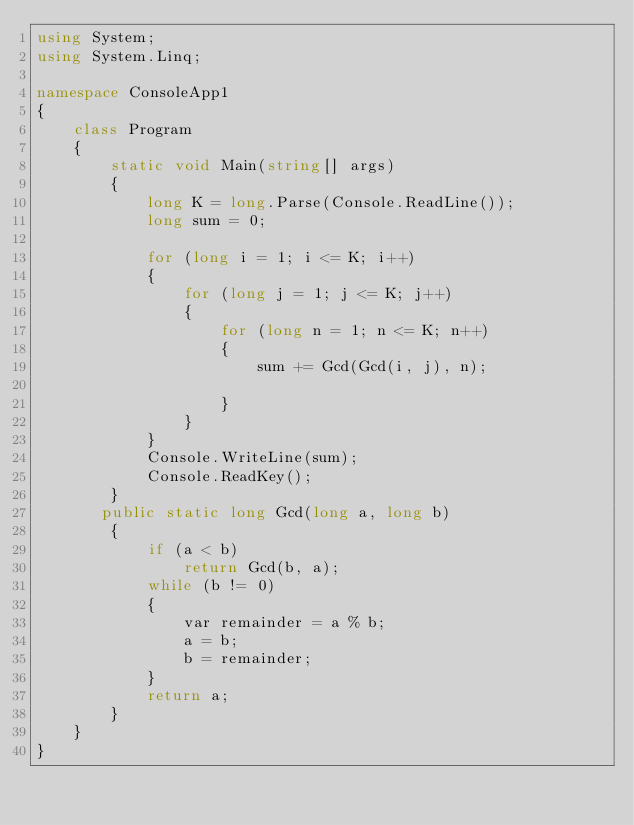Convert code to text. <code><loc_0><loc_0><loc_500><loc_500><_C#_>using System;
using System.Linq;

namespace ConsoleApp1
{
    class Program
    {
        static void Main(string[] args)
        {
            long K = long.Parse(Console.ReadLine());
            long sum = 0;

            for (long i = 1; i <= K; i++)
            {
                for (long j = 1; j <= K; j++)
                {
                    for (long n = 1; n <= K; n++)
                    {
                        sum += Gcd(Gcd(i, j), n);

                    }
                }
            }
            Console.WriteLine(sum);
            Console.ReadKey();
        }
       public static long Gcd(long a, long b)
        {
            if (a < b)
                return Gcd(b, a);
            while (b != 0)
            {
                var remainder = a % b;
                a = b;
                b = remainder;
            }
            return a;
        }
    }
}</code> 